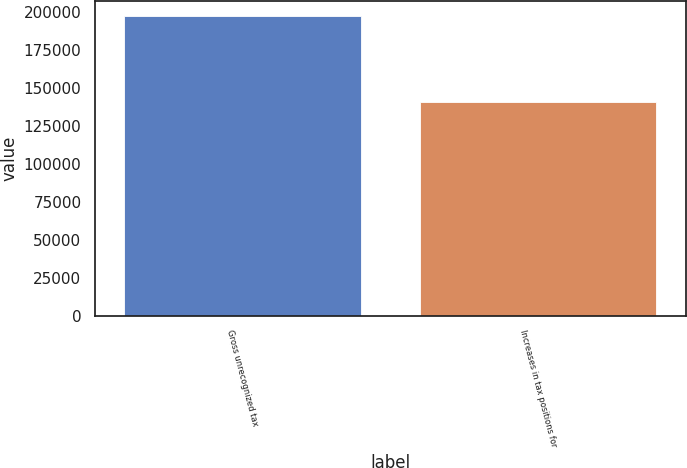Convert chart. <chart><loc_0><loc_0><loc_500><loc_500><bar_chart><fcel>Gross unrecognized tax<fcel>Increases in tax positions for<nl><fcel>197189<fcel>140513<nl></chart> 